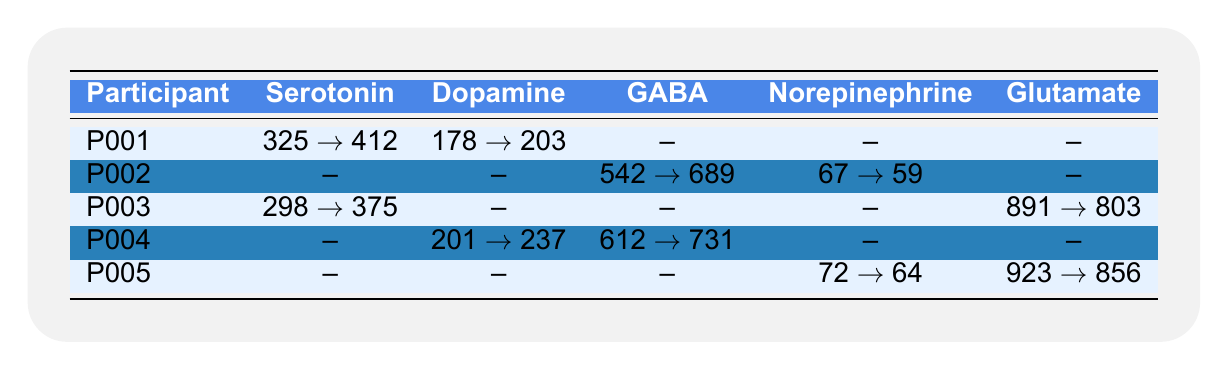What was the change in serotonin levels for participant P001? For participant P001, the serotonin level increased from 325 to 412 after the meditation retreat. The change can be calculated as 412 - 325 = 87.
Answer: 87 Did participant P002 experience an increase in GABA levels? Participant P002 showed an increase in GABA levels; they went from 542 to 689, which is an increase of 147.
Answer: Yes Which participant had the highest dopamine level after the retreat? Participant P004 had a dopamine level of 237 after the retreat, which is the highest level listed in the table for dopamine compared to participant P001's 203.
Answer: P004 What was the average change in norepinephrine levels among participants P002 and P005? P002’s norepinephrine level decreased from 67 to 59, while P005's decreased from 72 to 64. For P002, the change is 59 - 67 = -8, and for P005, it is 64 - 72 = -8. The average change is (-8 + -8) / 2 = -8.
Answer: -8 Which neurotransmitter showed a decrease for participant P003? For participant P003, Glutamate levels decreased from 891 to 803 after the retreat. The table indicates this from the information listed.
Answer: Glutamate Was there an overall increase in serotonin levels for all participants combined? For all participants with serotonin data: P001 had an increase of 87 (from 325 to 412) and P003 had an increase of 77 (from 298 to 375). There were no decreases reported, thus the overall change is positive.
Answer: Yes Which participant had neurotransmitter data listed for the most neurotransmitters? Participant P004 had values listed for both dopamine and GABA, which amounts to two neurotransmitters. Others had one or none.
Answer: P004 What was the difference in glutamate levels for participant P005 before and after the retreat? For P005, the glutamate levels changed from 923 to 856, so the difference is calculated as 923 - 856 = 67.
Answer: 67 Did GABA levels decrease for any participant? GABA levels decreased for participant P002, which went from 542 to 689 indicating an increase, so no participants experienced a decrease in GABA levels.
Answer: No Which participant had the largest increase in neurotransmitter levels across all measurements? Participant P002 had the largest increase in GABA of 147. The next highest was P001 with an increase of 87 in serotonin. Thus, P002 had the largest increase overall.
Answer: P002 